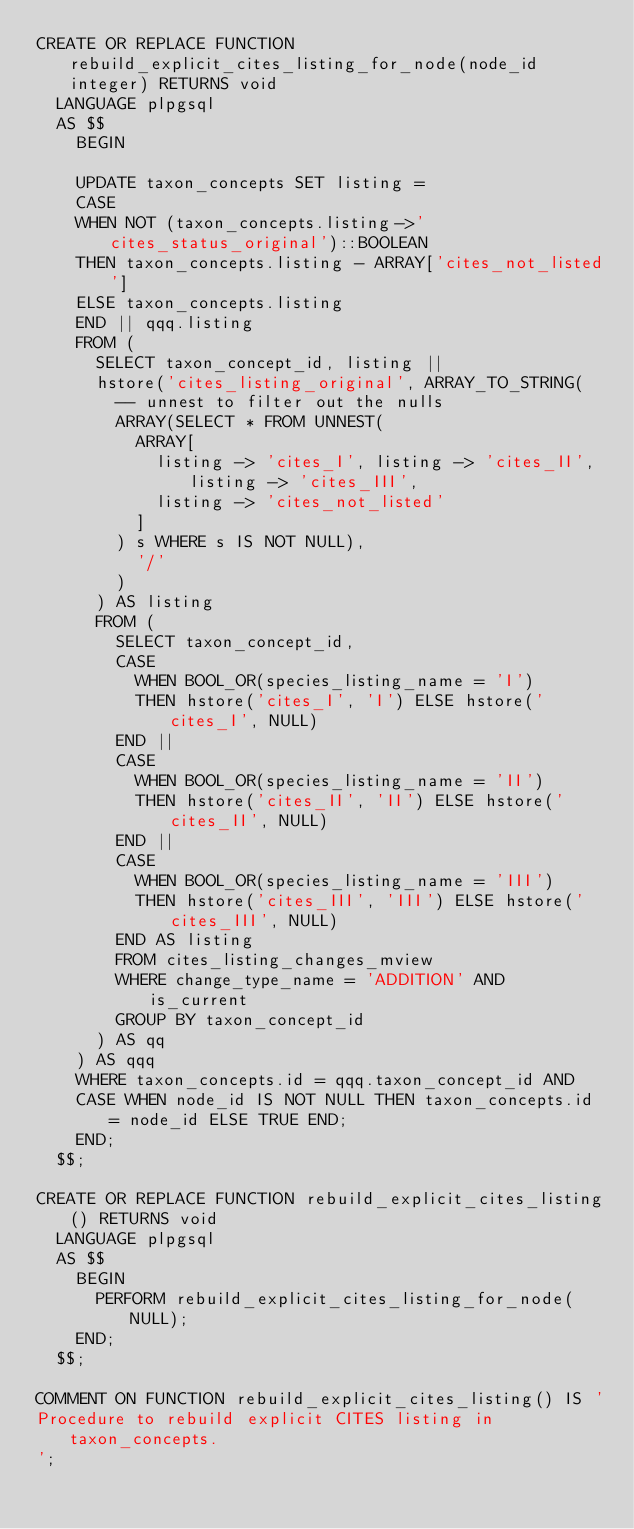<code> <loc_0><loc_0><loc_500><loc_500><_SQL_>CREATE OR REPLACE FUNCTION rebuild_explicit_cites_listing_for_node(node_id integer) RETURNS void
  LANGUAGE plpgsql
  AS $$
    BEGIN

    UPDATE taxon_concepts SET listing =
    CASE
    WHEN NOT (taxon_concepts.listing->'cites_status_original')::BOOLEAN
    THEN taxon_concepts.listing - ARRAY['cites_not_listed']
    ELSE taxon_concepts.listing
    END || qqq.listing
    FROM (
      SELECT taxon_concept_id, listing ||
      hstore('cites_listing_original', ARRAY_TO_STRING(
        -- unnest to filter out the nulls
        ARRAY(SELECT * FROM UNNEST(
          ARRAY[
            listing -> 'cites_I', listing -> 'cites_II', listing -> 'cites_III',
            listing -> 'cites_not_listed'
          ]
        ) s WHERE s IS NOT NULL),
          '/'
        )
      ) AS listing
      FROM (
        SELECT taxon_concept_id, 
        CASE 
          WHEN BOOL_OR(species_listing_name = 'I') 
          THEN hstore('cites_I', 'I') ELSE hstore('cites_I', NULL)
        END || 
        CASE
          WHEN BOOL_OR(species_listing_name = 'II') 
          THEN hstore('cites_II', 'II') ELSE hstore('cites_II', NULL)
        END ||
        CASE
          WHEN BOOL_OR(species_listing_name = 'III') 
          THEN hstore('cites_III', 'III') ELSE hstore('cites_III', NULL)
        END AS listing
        FROM cites_listing_changes_mview
        WHERE change_type_name = 'ADDITION' AND is_current
        GROUP BY taxon_concept_id
      ) AS qq
    ) AS qqq
    WHERE taxon_concepts.id = qqq.taxon_concept_id AND
    CASE WHEN node_id IS NOT NULL THEN taxon_concepts.id = node_id ELSE TRUE END;
    END;
  $$;

CREATE OR REPLACE FUNCTION rebuild_explicit_cites_listing() RETURNS void
  LANGUAGE plpgsql
  AS $$
    BEGIN
      PERFORM rebuild_explicit_cites_listing_for_node(NULL);
    END;
  $$;

COMMENT ON FUNCTION rebuild_explicit_cites_listing() IS '
Procedure to rebuild explicit CITES listing in taxon_concepts.
';
</code> 